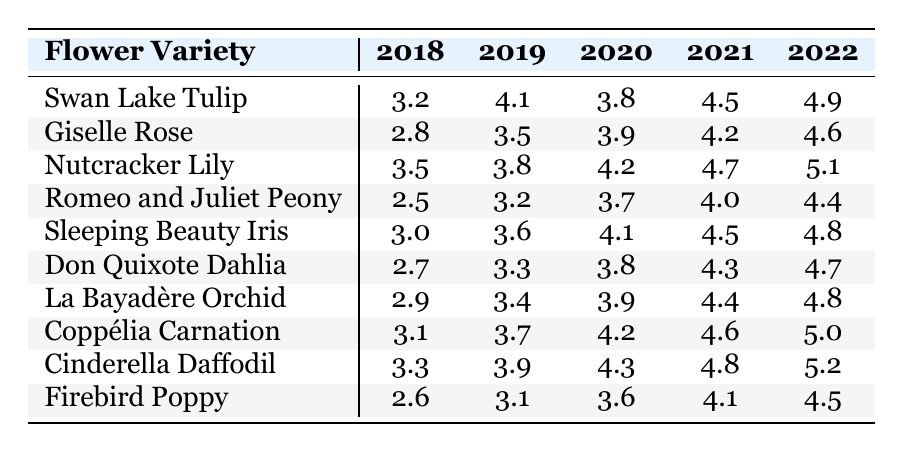What was the growth rate of the Swan Lake Tulip in 2022? The growth rate of the Swan Lake Tulip in 2022 is the value listed for that year in the table, which is 4.9.
Answer: 4.9 Which flower had the highest growth rate in 2021? By inspecting the values for 2021, the Nutcracker Lily has the highest growth rate at 4.7.
Answer: Nutcracker Lily What is the average growth rate of the Cinderella Daffodil over all the years? To find the average, sum the values for the Cinderella Daffodil: (3.3 + 3.9 + 4.3 + 4.8 + 5.2) = 21.5. Then divide by the number of years (5): 21.5 / 5 = 4.3.
Answer: 4.3 Did the growth rate of the Romeo and Juliet Peony increase every year? Looking at the values for each year, the growth rates are: 2.5, 3.2, 3.7, 4.0, and 4.4. Since all values show an increase from the previous year, the answer is yes.
Answer: Yes Which flower variety showed the greatest overall increase in growth rate from 2018 to 2022? To find the greatest increase, calculate the difference in growth rates for each flower from 2018 to 2022. The Swan Lake Tulip grew from 3.2 to 4.9, an increase of 1.7. The greatest increase is from the Nutcracker Lily, which grows from 3.5 to 5.1, an increase of 1.6. That shows the highest rate belongs to the Swan Lake Tulip at 1.7.
Answer: Swan Lake Tulip What was the percentage increase in growth rate for the Firebird Poppy from 2018 to 2022? The growth rate in 2018 was 2.6 and in 2022 it was 4.5. To find the percentage increase, use the formula [(4.5 - 2.6) / 2.6] * 100, which calculates to approximately 73.08%.
Answer: 73.08% Which year had the highest average growth rate across all flower varieties? First, calculate the average for each year: 2018: (3.2 + 2.8 + 3.5 + 2.5 + 3.0 + 2.7 + 2.9 + 3.1 + 3.3 + 2.6) / 10 = 2.94, 2019: (4.1 + 3.5 + 3.8 + 3.2 + 3.6 + 3.3 + 3.4 + 3.7 + 3.9 + 3.1) / 10 = 3.57, 2020: (3.8 + 3.9 + 4.2 + 3.7 + 4.1 + 3.8 + 3.9 + 4.2 + 4.3 + 3.6) / 10 = 4.04, 2021: (4.5 + 4.2 + 4.7 + 4.0 + 4.5 + 4.3 + 4.4 + 4.6 + 4.8 + 4.1) / 10 = 4.44, and 2022: (4.9 + 4.6 + 5.1 + 4.4 + 4.8 + 4.7 + 4.8 + 5.0 + 5.2 + 4.5) / 10 = 4.74. The highest average is for 2022.
Answer: 2022 Was there any year where the growth rate for the Don Quixote Dahlia was lower than 3.0? Checking the values for the Don Quixote Dahlia, the rates are: 2.7, 3.3, 3.8, 4.3, and 4.7. The first value, 2.7, is lower than 3.0, so yes, there was a year with a lower growth rate.
Answer: Yes Which flower had the most consistent growth pattern (smallest variation in growth rates)? To determine consistency, calculate the range (maximum - minimum) of growth rates for each flower. The Giselle Rose has growth rates of 2.8, 3.5, 3.9, 4.2, and 4.6 (range = 4.6 - 2.8 = 1.8), while watching others, the Coppélia Carnation shows a range of only 1.9. Comparing these values, the Giselle Rose has the smallest range, indicating more consistent growth.
Answer: Giselle Rose 